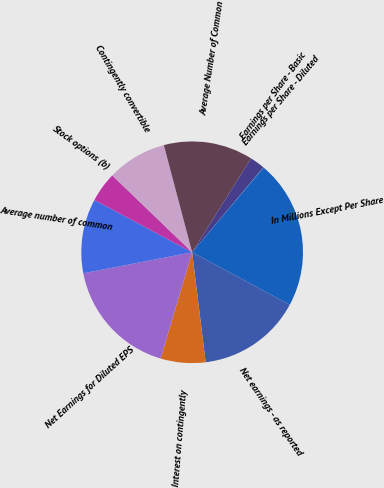<chart> <loc_0><loc_0><loc_500><loc_500><pie_chart><fcel>In Millions Except Per Share<fcel>Net earnings - as reported<fcel>Interest on contingently<fcel>Net Earnings for Diluted EPS<fcel>Average number of common<fcel>Stock options (b)<fcel>Contingently convertible<fcel>Average Number of Common<fcel>Earnings per Share - Basic<fcel>Earnings per Share - Diluted<nl><fcel>21.7%<fcel>15.2%<fcel>6.53%<fcel>17.37%<fcel>10.87%<fcel>4.37%<fcel>8.7%<fcel>13.03%<fcel>2.2%<fcel>0.03%<nl></chart> 